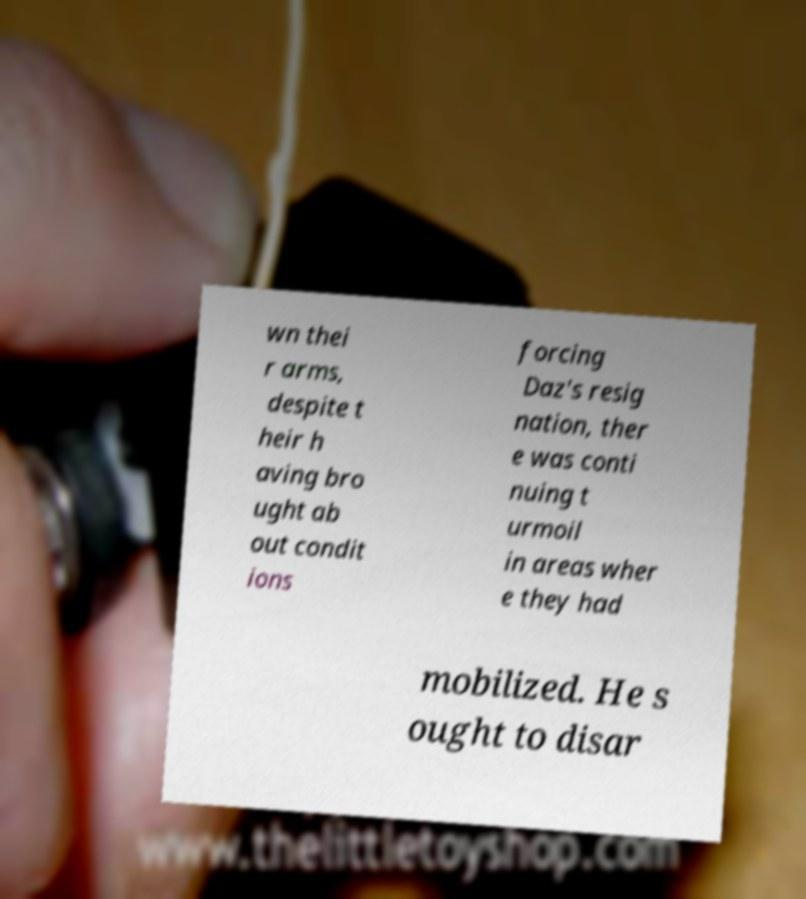For documentation purposes, I need the text within this image transcribed. Could you provide that? wn thei r arms, despite t heir h aving bro ught ab out condit ions forcing Daz's resig nation, ther e was conti nuing t urmoil in areas wher e they had mobilized. He s ought to disar 